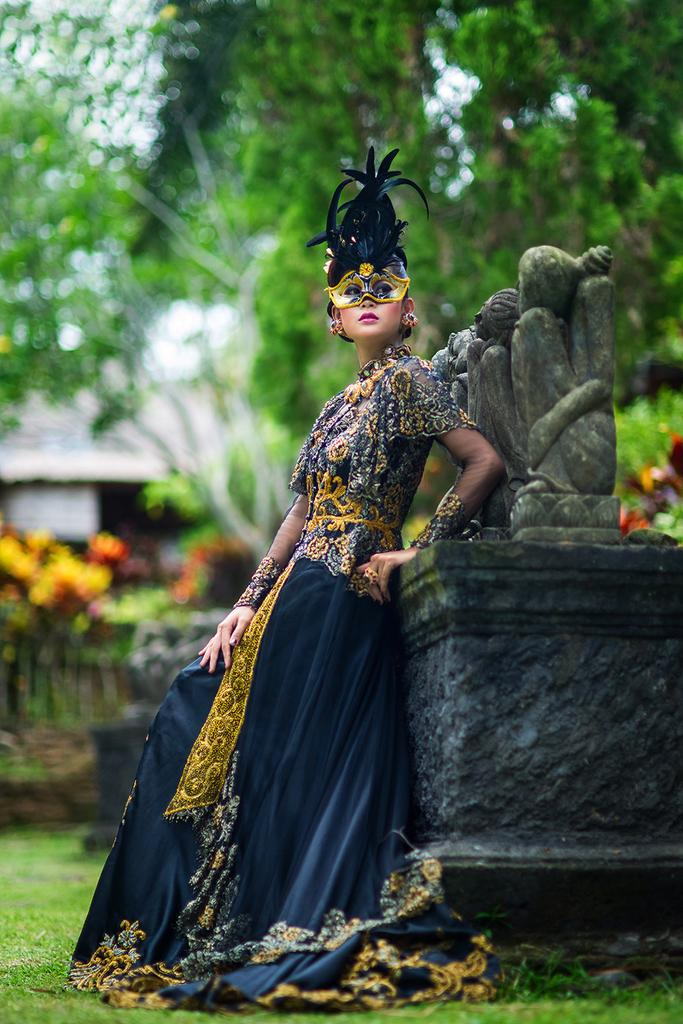What is the person in the image wearing? The person is wearing a blue and yellow dress in the image. Can you describe any additional accessories the person is wearing? The person is wearing a mask. What other object can be seen in the image? There is a statue in the image. What type of natural environment is visible in the image? There are trees in the image. What type of goat can be seen climbing the statue in the image? There is no goat present in the image, and therefore no such activity can be observed. 